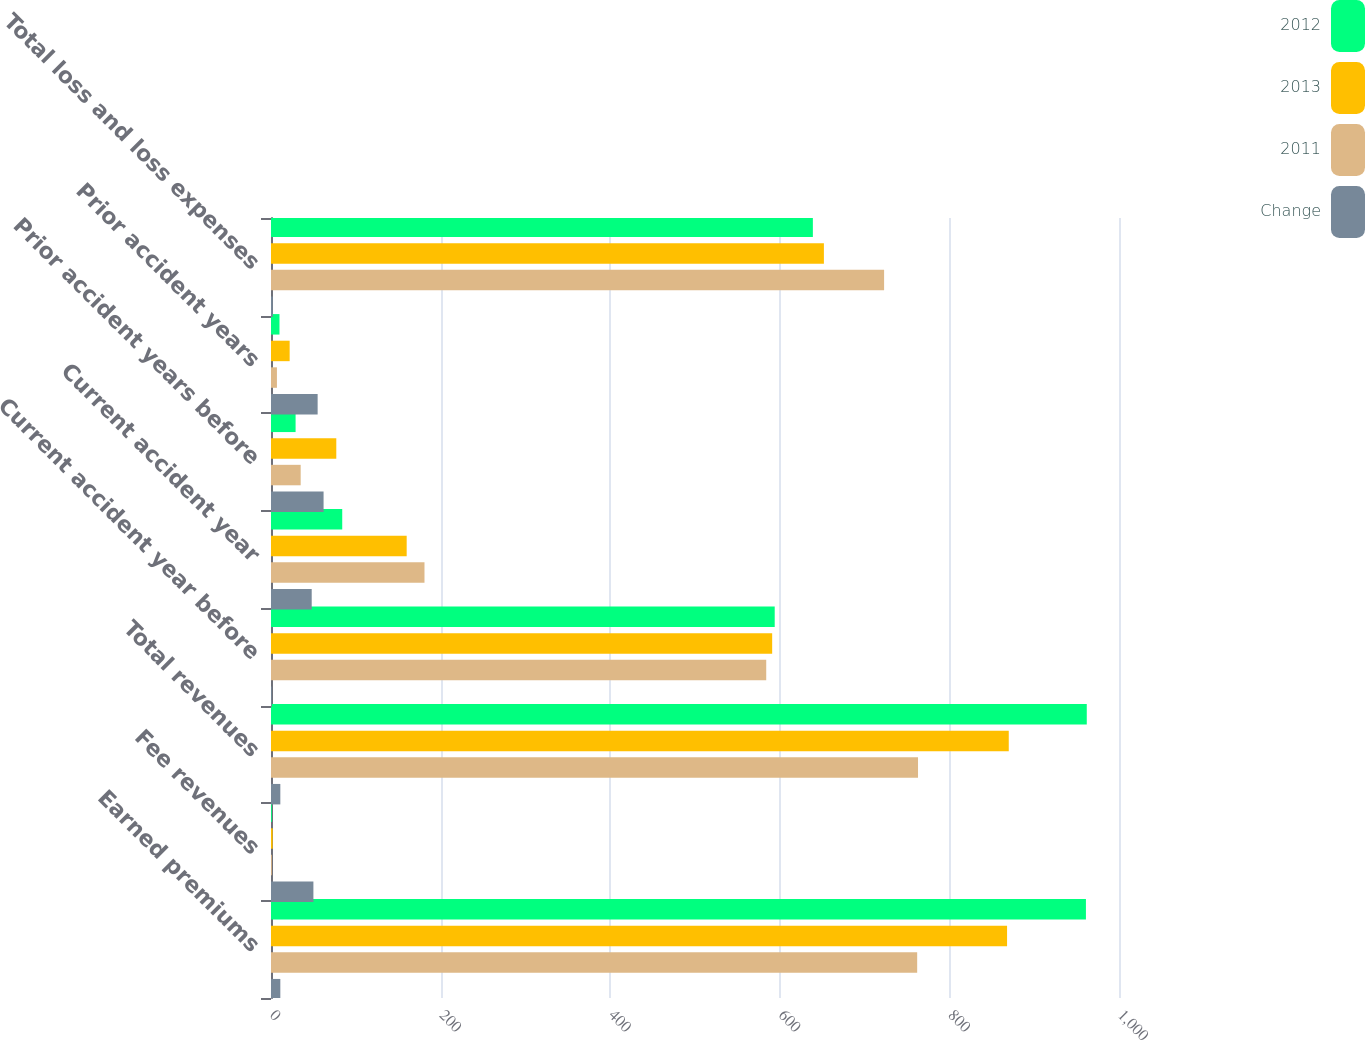Convert chart to OTSL. <chart><loc_0><loc_0><loc_500><loc_500><stacked_bar_chart><ecel><fcel>Earned premiums<fcel>Fee revenues<fcel>Total revenues<fcel>Current accident year before<fcel>Current accident year<fcel>Prior accident years before<fcel>Prior accident years<fcel>Total loss and loss expenses<nl><fcel>2012<fcel>961<fcel>1<fcel>962<fcel>594<fcel>84<fcel>29<fcel>10<fcel>639<nl><fcel>2013<fcel>868<fcel>2<fcel>870<fcel>591<fcel>160<fcel>77<fcel>22<fcel>652<nl><fcel>2011<fcel>762<fcel>1<fcel>763<fcel>584<fcel>181<fcel>35<fcel>7<fcel>723<nl><fcel>Change<fcel>11<fcel>50<fcel>11<fcel>1<fcel>48<fcel>62<fcel>55<fcel>2<nl></chart> 